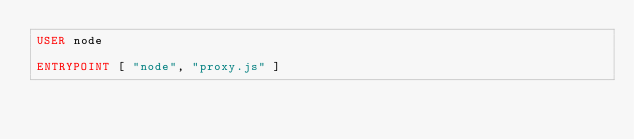<code> <loc_0><loc_0><loc_500><loc_500><_Dockerfile_>USER node

ENTRYPOINT [ "node", "proxy.js" ]
</code> 